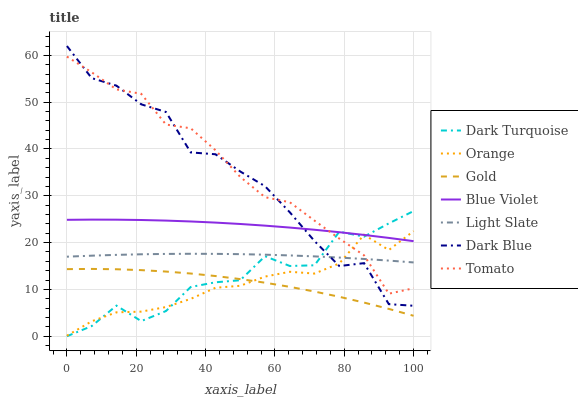Does Gold have the minimum area under the curve?
Answer yes or no. No. Does Gold have the maximum area under the curve?
Answer yes or no. No. Is Gold the smoothest?
Answer yes or no. No. Is Gold the roughest?
Answer yes or no. No. Does Gold have the lowest value?
Answer yes or no. No. Does Light Slate have the highest value?
Answer yes or no. No. Is Gold less than Tomato?
Answer yes or no. Yes. Is Dark Blue greater than Gold?
Answer yes or no. Yes. Does Gold intersect Tomato?
Answer yes or no. No. 